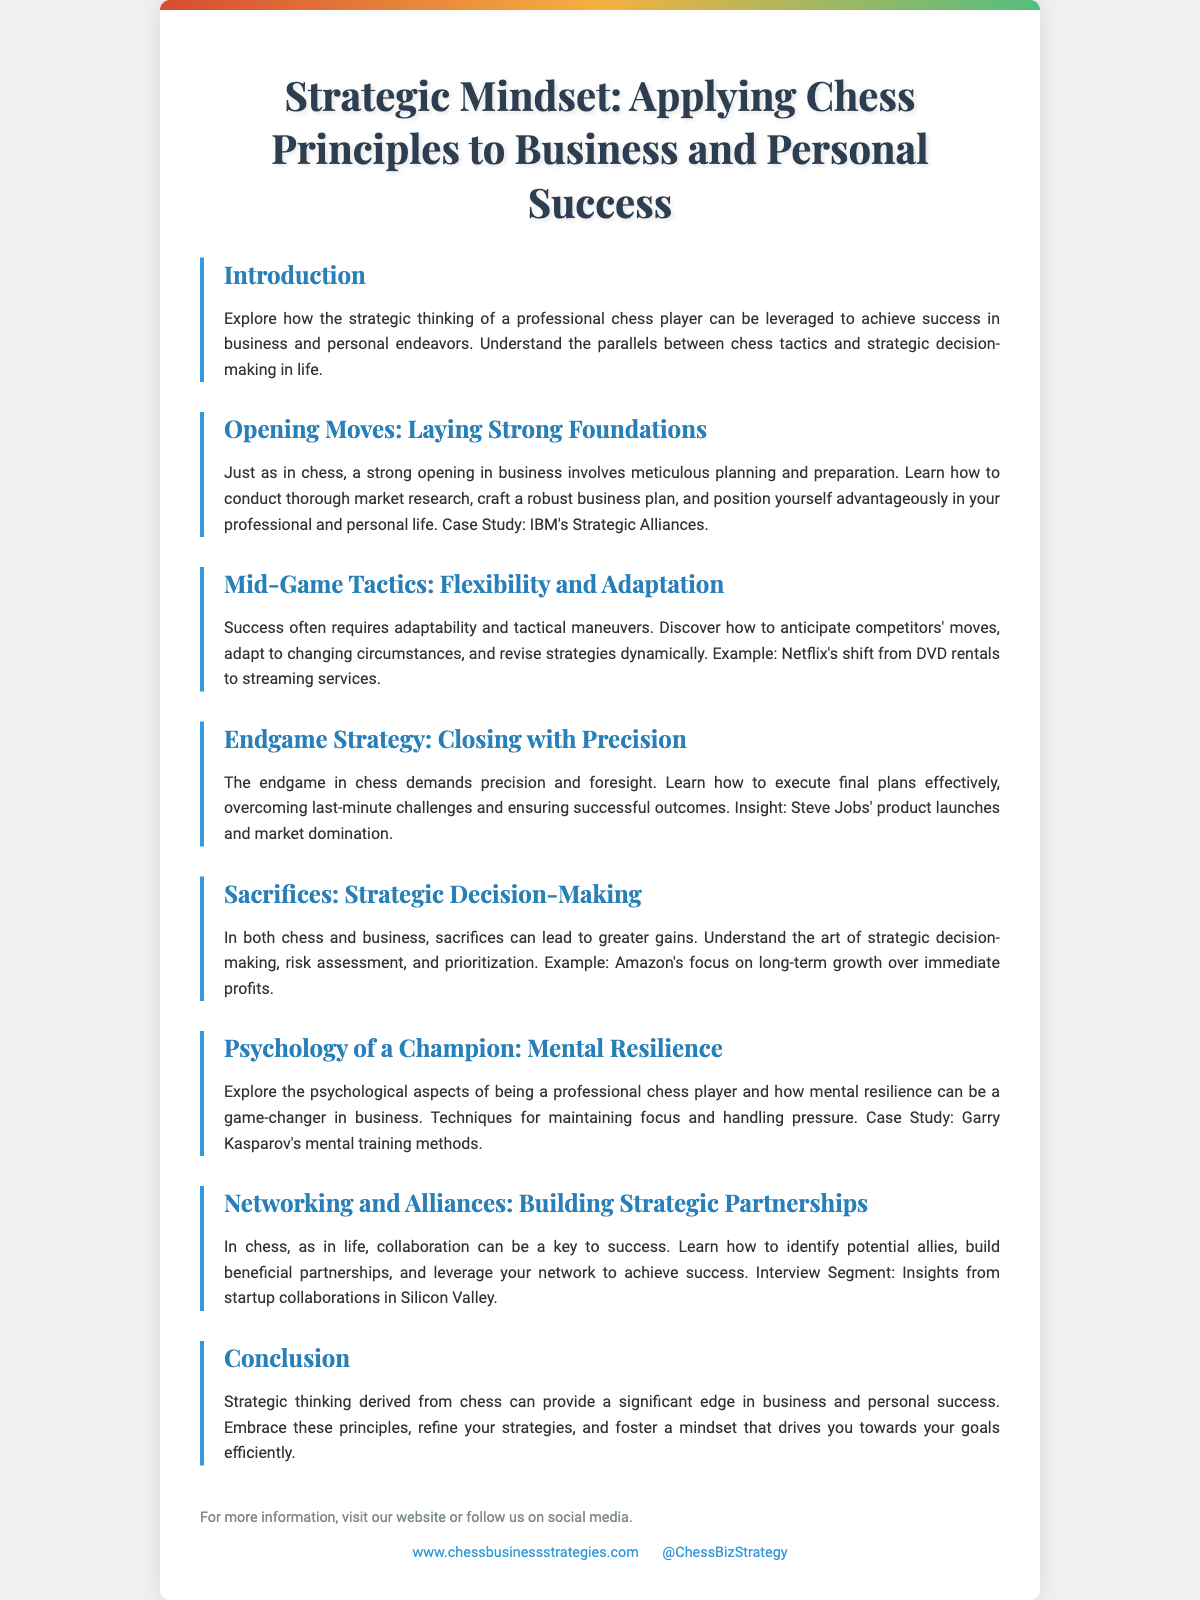What is the title of the document? The title of the document is stated prominently at the top of the Playbill.
Answer: Strategic Mindset: Applying Chess Principles to Business and Personal Success What case study is mentioned in the section about Opening Moves? The case study provides an example of a successful company that illustrates the concepts discussed in the section.
Answer: IBM's Strategic Alliances What example is used in the Mid-Game Tactics section? The document includes an example to illustrate the importance of adaptability in business situations.
Answer: Netflix's shift from DVD rentals to streaming services What is highlighted in the Endgame Strategy section? This section discusses a key aspect of executing final plans effectively in business, supported by an example.
Answer: Steve Jobs' product launches and market domination Which chess player’s methods are referenced in the Psychology of a Champion section? The document highlights a famous chess player's approach to mental training in relation to business strategies.
Answer: Garry Kasparov's mental training methods What is emphasized in the Networking and Alliances section? This section discusses the importance of certain relationships for achieving business success.
Answer: Building beneficial partnerships What are strong openings in business compared to in chess? The document draws parallels between two different contexts to demonstrate strategic foundations.
Answer: Laying Strong Foundations What type of decision-making is discussed in the Sacrifices section? The section elaborates on a specific approach taken in both chess and business that leads to success.
Answer: Strategic Decision-Making 